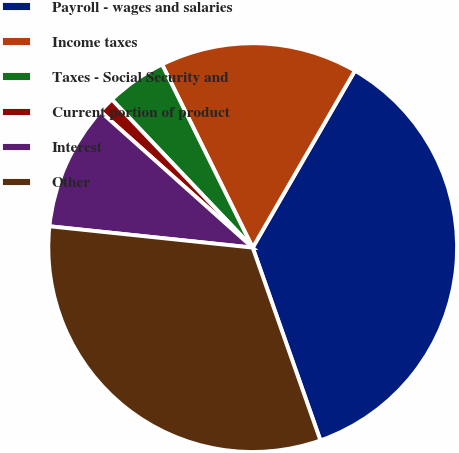Convert chart. <chart><loc_0><loc_0><loc_500><loc_500><pie_chart><fcel>Payroll - wages and salaries<fcel>Income taxes<fcel>Taxes - Social Security and<fcel>Current portion of product<fcel>Interest<fcel>Other<nl><fcel>36.28%<fcel>15.65%<fcel>4.79%<fcel>1.29%<fcel>9.94%<fcel>32.04%<nl></chart> 